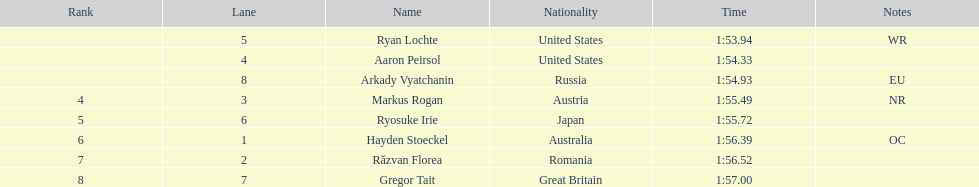How long did it take ryosuke irie to finish? 1:55.72. 